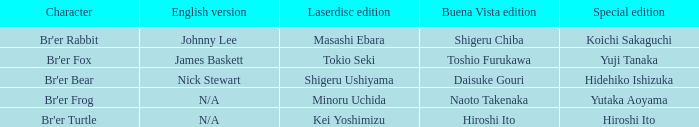Who is the character where the special edition is koichi sakaguchi? Br'er Rabbit. 